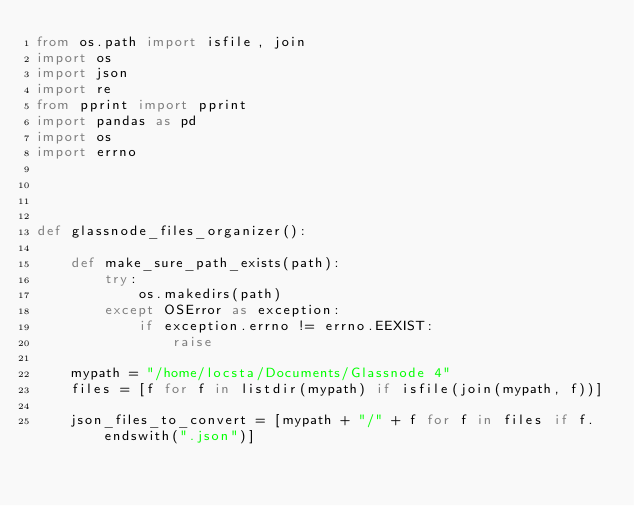<code> <loc_0><loc_0><loc_500><loc_500><_Python_>from os.path import isfile, join
import os
import json
import re
from pprint import pprint
import pandas as pd
import os
import errno




def glassnode_files_organizer():
    
    def make_sure_path_exists(path):
        try:
            os.makedirs(path)
        except OSError as exception:
            if exception.errno != errno.EEXIST:
                raise

    mypath = "/home/locsta/Documents/Glassnode 4"
    files = [f for f in listdir(mypath) if isfile(join(mypath, f))]

    json_files_to_convert = [mypath + "/" + f for f in files if f.endswith(".json")]</code> 